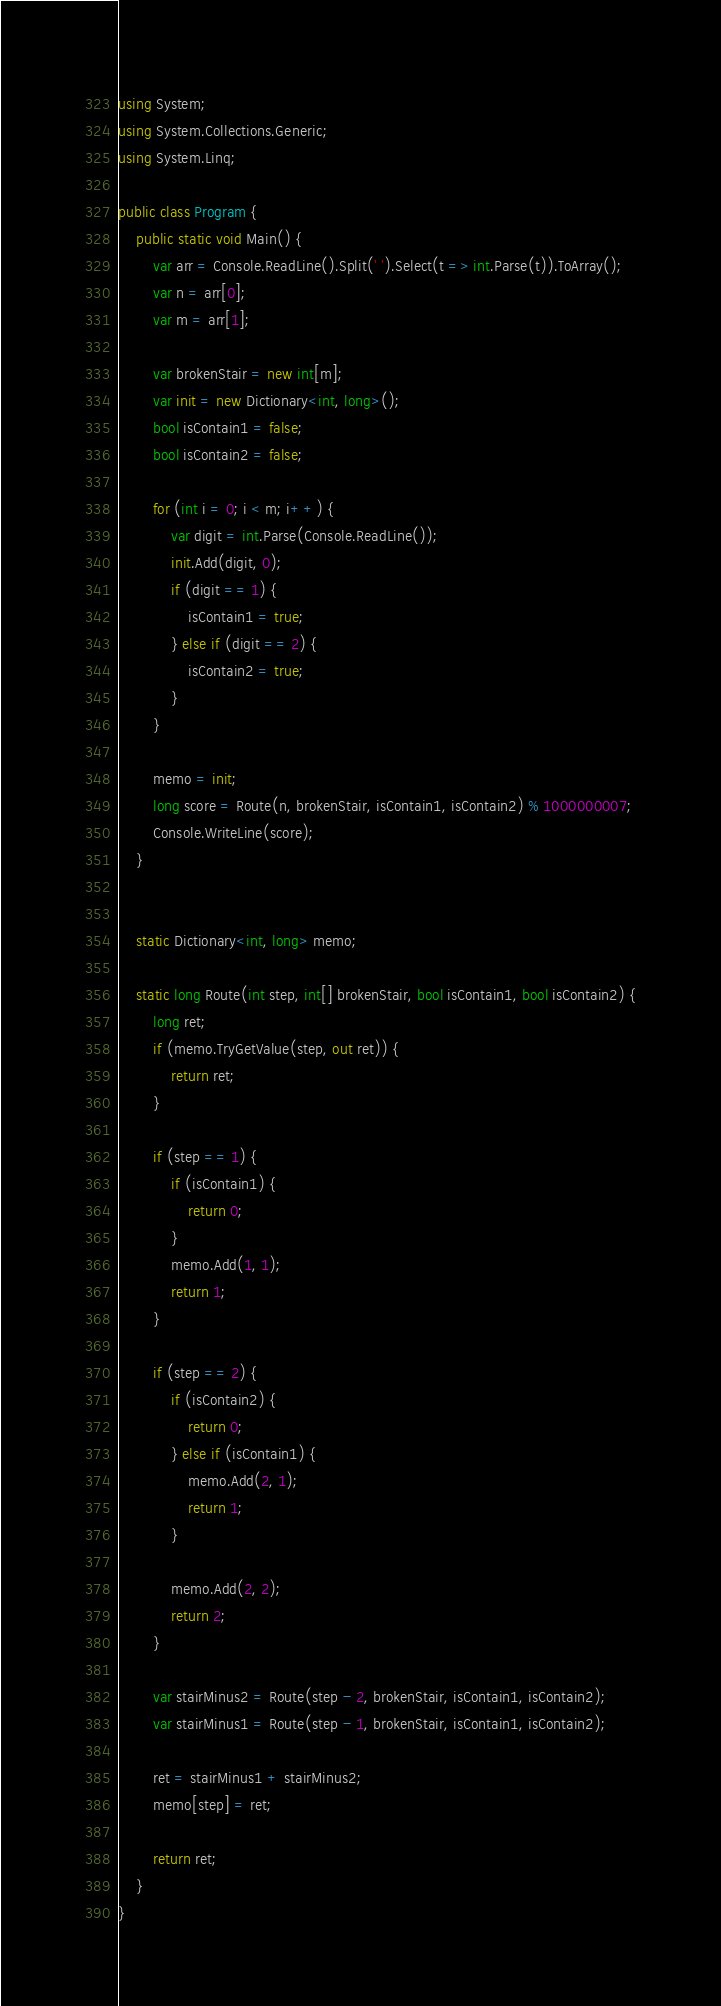Convert code to text. <code><loc_0><loc_0><loc_500><loc_500><_C#_>using System;
using System.Collections.Generic;
using System.Linq;

public class Program {
    public static void Main() {
        var arr = Console.ReadLine().Split(' ').Select(t => int.Parse(t)).ToArray();
        var n = arr[0];
        var m = arr[1];

        var brokenStair = new int[m];
        var init = new Dictionary<int, long>();
        bool isContain1 = false;
        bool isContain2 = false;

        for (int i = 0; i < m; i++) {
            var digit = int.Parse(Console.ReadLine());
            init.Add(digit, 0);
            if (digit == 1) {
                isContain1 = true;
            } else if (digit == 2) {
                isContain2 = true;
            }
        }

        memo = init;
        long score = Route(n, brokenStair, isContain1, isContain2) % 1000000007;
        Console.WriteLine(score);
    }


    static Dictionary<int, long> memo;

    static long Route(int step, int[] brokenStair, bool isContain1, bool isContain2) {
        long ret;
        if (memo.TryGetValue(step, out ret)) {
            return ret;
        }

        if (step == 1) {
            if (isContain1) {
                return 0;
            }
            memo.Add(1, 1);
            return 1;
        }

        if (step == 2) {
            if (isContain2) {
                return 0;
            } else if (isContain1) {
                memo.Add(2, 1);
                return 1;
            }

            memo.Add(2, 2);
            return 2;
        }

        var stairMinus2 = Route(step - 2, brokenStair, isContain1, isContain2);
        var stairMinus1 = Route(step - 1, brokenStair, isContain1, isContain2);

        ret = stairMinus1 + stairMinus2;
        memo[step] = ret;

        return ret;
    }
}
</code> 